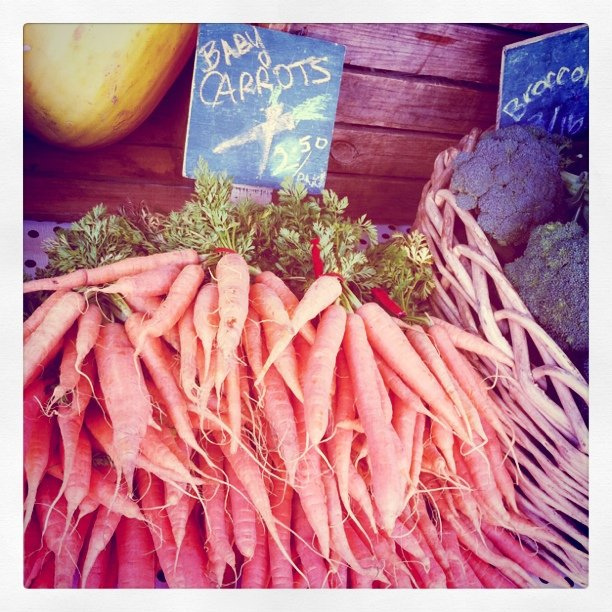How much do the baby carrots cost per pound? The sign indicates that the baby carrots cost $2.50 per pound. Are the carrots on sale individually or by weight? The carrots are sold by weight, as indicated by the price per pound notice by the carrots. 